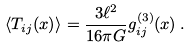<formula> <loc_0><loc_0><loc_500><loc_500>\langle T _ { i j } ( x ) \rangle = \frac { 3 \ell ^ { 2 } } { 1 6 \pi G } g ^ { ( 3 ) } _ { i j } ( x ) \, .</formula> 